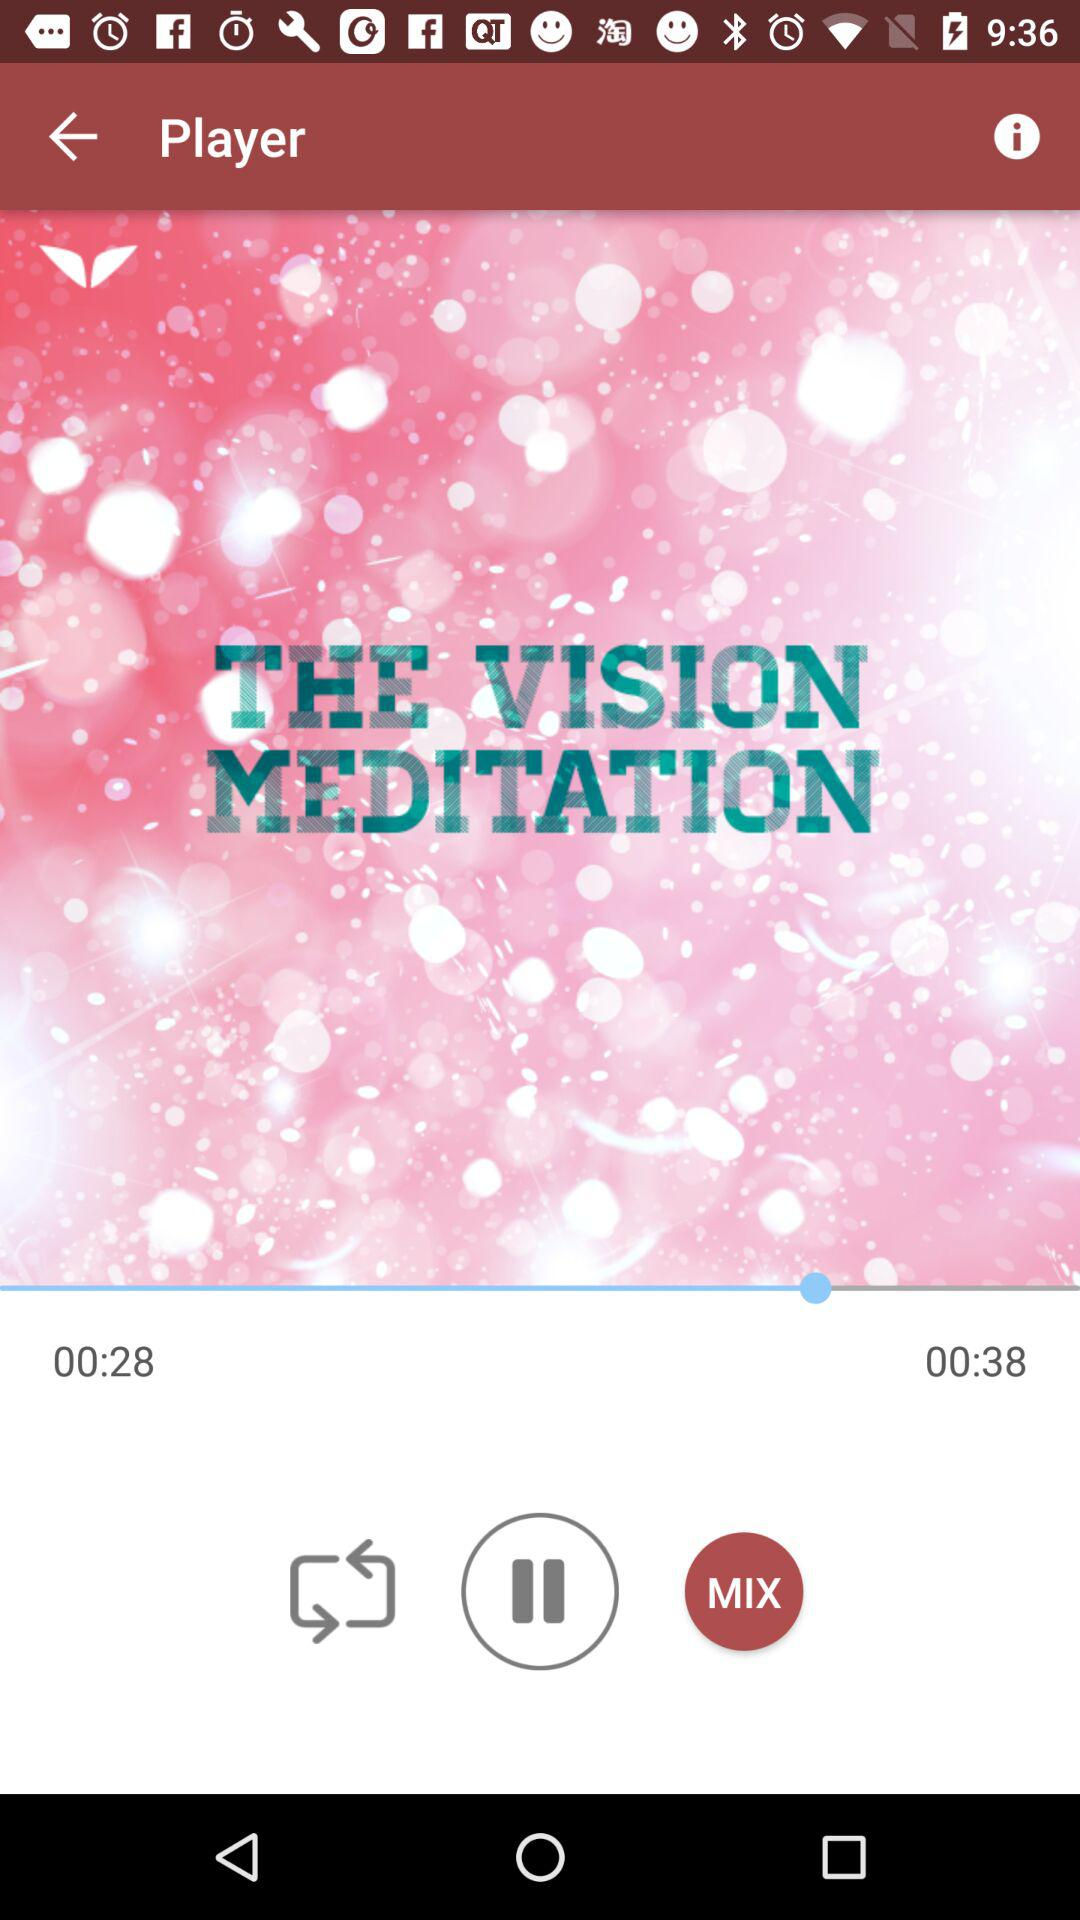How many more seconds are in the second time than the first?
Answer the question using a single word or phrase. 10 